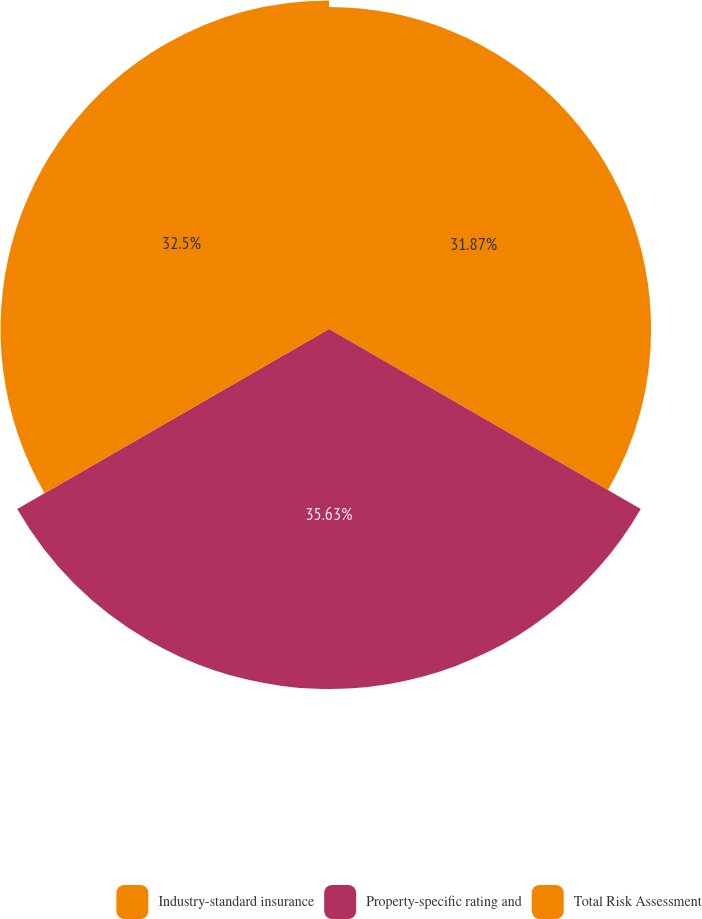<chart> <loc_0><loc_0><loc_500><loc_500><pie_chart><fcel>Industry-standard insurance<fcel>Property-specific rating and<fcel>Total Risk Assessment<nl><fcel>31.87%<fcel>35.62%<fcel>32.5%<nl></chart> 